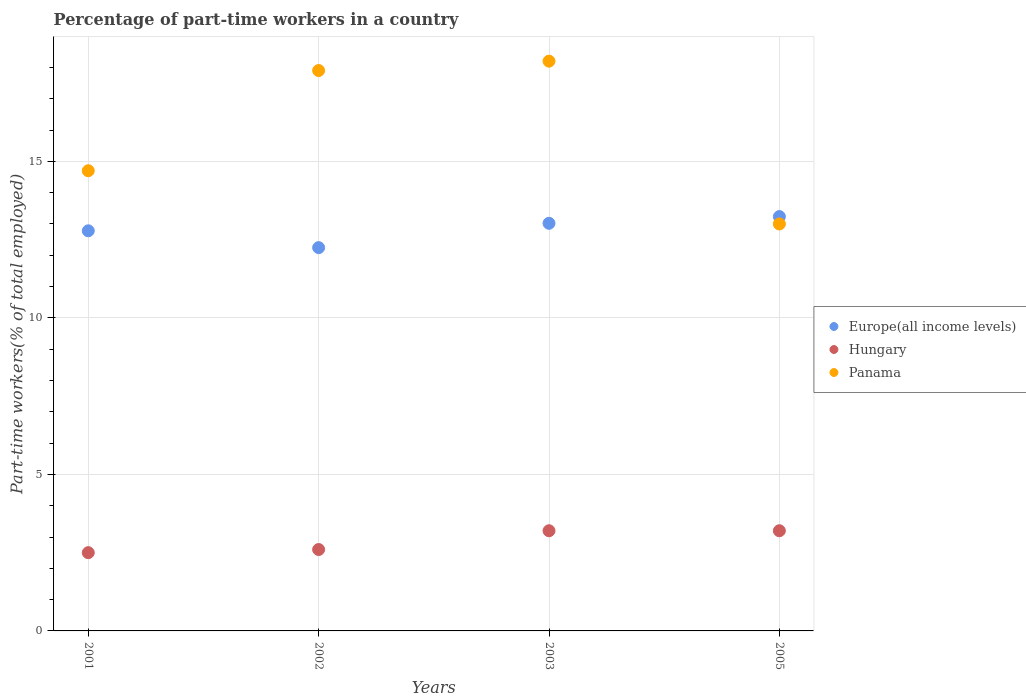How many different coloured dotlines are there?
Offer a very short reply. 3. What is the percentage of part-time workers in Hungary in 2002?
Provide a short and direct response. 2.6. Across all years, what is the maximum percentage of part-time workers in Panama?
Offer a very short reply. 18.2. In which year was the percentage of part-time workers in Hungary maximum?
Provide a succinct answer. 2003. What is the total percentage of part-time workers in Europe(all income levels) in the graph?
Keep it short and to the point. 51.28. What is the difference between the percentage of part-time workers in Europe(all income levels) in 2001 and that in 2005?
Ensure brevity in your answer.  -0.45. What is the difference between the percentage of part-time workers in Panama in 2001 and the percentage of part-time workers in Europe(all income levels) in 2005?
Provide a succinct answer. 1.46. What is the average percentage of part-time workers in Panama per year?
Ensure brevity in your answer.  15.95. In the year 2001, what is the difference between the percentage of part-time workers in Panama and percentage of part-time workers in Europe(all income levels)?
Your response must be concise. 1.92. In how many years, is the percentage of part-time workers in Europe(all income levels) greater than 8 %?
Provide a succinct answer. 4. What is the ratio of the percentage of part-time workers in Panama in 2001 to that in 2005?
Your response must be concise. 1.13. Is the percentage of part-time workers in Hungary in 2001 less than that in 2005?
Ensure brevity in your answer.  Yes. What is the difference between the highest and the second highest percentage of part-time workers in Europe(all income levels)?
Your answer should be compact. 0.21. What is the difference between the highest and the lowest percentage of part-time workers in Europe(all income levels)?
Your response must be concise. 0.99. Is the percentage of part-time workers in Panama strictly greater than the percentage of part-time workers in Hungary over the years?
Your answer should be very brief. Yes. Is the percentage of part-time workers in Panama strictly less than the percentage of part-time workers in Europe(all income levels) over the years?
Your response must be concise. No. How many dotlines are there?
Ensure brevity in your answer.  3. What is the difference between two consecutive major ticks on the Y-axis?
Provide a succinct answer. 5. Does the graph contain any zero values?
Offer a very short reply. No. Where does the legend appear in the graph?
Your response must be concise. Center right. How are the legend labels stacked?
Make the answer very short. Vertical. What is the title of the graph?
Make the answer very short. Percentage of part-time workers in a country. Does "Botswana" appear as one of the legend labels in the graph?
Give a very brief answer. No. What is the label or title of the Y-axis?
Provide a short and direct response. Part-time workers(% of total employed). What is the Part-time workers(% of total employed) in Europe(all income levels) in 2001?
Give a very brief answer. 12.78. What is the Part-time workers(% of total employed) of Panama in 2001?
Provide a short and direct response. 14.7. What is the Part-time workers(% of total employed) in Europe(all income levels) in 2002?
Your answer should be compact. 12.24. What is the Part-time workers(% of total employed) of Hungary in 2002?
Give a very brief answer. 2.6. What is the Part-time workers(% of total employed) in Panama in 2002?
Offer a terse response. 17.9. What is the Part-time workers(% of total employed) in Europe(all income levels) in 2003?
Your answer should be very brief. 13.02. What is the Part-time workers(% of total employed) of Hungary in 2003?
Offer a terse response. 3.2. What is the Part-time workers(% of total employed) in Panama in 2003?
Keep it short and to the point. 18.2. What is the Part-time workers(% of total employed) in Europe(all income levels) in 2005?
Keep it short and to the point. 13.24. What is the Part-time workers(% of total employed) of Hungary in 2005?
Offer a very short reply. 3.2. What is the Part-time workers(% of total employed) of Panama in 2005?
Provide a short and direct response. 13. Across all years, what is the maximum Part-time workers(% of total employed) of Europe(all income levels)?
Make the answer very short. 13.24. Across all years, what is the maximum Part-time workers(% of total employed) of Hungary?
Make the answer very short. 3.2. Across all years, what is the maximum Part-time workers(% of total employed) in Panama?
Provide a succinct answer. 18.2. Across all years, what is the minimum Part-time workers(% of total employed) in Europe(all income levels)?
Keep it short and to the point. 12.24. What is the total Part-time workers(% of total employed) in Europe(all income levels) in the graph?
Your answer should be compact. 51.28. What is the total Part-time workers(% of total employed) in Hungary in the graph?
Ensure brevity in your answer.  11.5. What is the total Part-time workers(% of total employed) in Panama in the graph?
Offer a very short reply. 63.8. What is the difference between the Part-time workers(% of total employed) of Europe(all income levels) in 2001 and that in 2002?
Ensure brevity in your answer.  0.54. What is the difference between the Part-time workers(% of total employed) of Europe(all income levels) in 2001 and that in 2003?
Make the answer very short. -0.24. What is the difference between the Part-time workers(% of total employed) in Europe(all income levels) in 2001 and that in 2005?
Keep it short and to the point. -0.45. What is the difference between the Part-time workers(% of total employed) in Europe(all income levels) in 2002 and that in 2003?
Your answer should be compact. -0.78. What is the difference between the Part-time workers(% of total employed) of Europe(all income levels) in 2002 and that in 2005?
Provide a short and direct response. -0.99. What is the difference between the Part-time workers(% of total employed) in Hungary in 2002 and that in 2005?
Offer a very short reply. -0.6. What is the difference between the Part-time workers(% of total employed) of Europe(all income levels) in 2003 and that in 2005?
Keep it short and to the point. -0.21. What is the difference between the Part-time workers(% of total employed) in Hungary in 2003 and that in 2005?
Offer a very short reply. 0. What is the difference between the Part-time workers(% of total employed) of Europe(all income levels) in 2001 and the Part-time workers(% of total employed) of Hungary in 2002?
Provide a short and direct response. 10.18. What is the difference between the Part-time workers(% of total employed) in Europe(all income levels) in 2001 and the Part-time workers(% of total employed) in Panama in 2002?
Give a very brief answer. -5.12. What is the difference between the Part-time workers(% of total employed) of Hungary in 2001 and the Part-time workers(% of total employed) of Panama in 2002?
Your answer should be compact. -15.4. What is the difference between the Part-time workers(% of total employed) in Europe(all income levels) in 2001 and the Part-time workers(% of total employed) in Hungary in 2003?
Keep it short and to the point. 9.58. What is the difference between the Part-time workers(% of total employed) in Europe(all income levels) in 2001 and the Part-time workers(% of total employed) in Panama in 2003?
Your answer should be compact. -5.42. What is the difference between the Part-time workers(% of total employed) in Hungary in 2001 and the Part-time workers(% of total employed) in Panama in 2003?
Provide a short and direct response. -15.7. What is the difference between the Part-time workers(% of total employed) in Europe(all income levels) in 2001 and the Part-time workers(% of total employed) in Hungary in 2005?
Provide a short and direct response. 9.58. What is the difference between the Part-time workers(% of total employed) in Europe(all income levels) in 2001 and the Part-time workers(% of total employed) in Panama in 2005?
Keep it short and to the point. -0.22. What is the difference between the Part-time workers(% of total employed) of Hungary in 2001 and the Part-time workers(% of total employed) of Panama in 2005?
Give a very brief answer. -10.5. What is the difference between the Part-time workers(% of total employed) of Europe(all income levels) in 2002 and the Part-time workers(% of total employed) of Hungary in 2003?
Provide a short and direct response. 9.04. What is the difference between the Part-time workers(% of total employed) in Europe(all income levels) in 2002 and the Part-time workers(% of total employed) in Panama in 2003?
Your answer should be very brief. -5.96. What is the difference between the Part-time workers(% of total employed) in Hungary in 2002 and the Part-time workers(% of total employed) in Panama in 2003?
Provide a succinct answer. -15.6. What is the difference between the Part-time workers(% of total employed) in Europe(all income levels) in 2002 and the Part-time workers(% of total employed) in Hungary in 2005?
Make the answer very short. 9.04. What is the difference between the Part-time workers(% of total employed) of Europe(all income levels) in 2002 and the Part-time workers(% of total employed) of Panama in 2005?
Make the answer very short. -0.76. What is the difference between the Part-time workers(% of total employed) of Europe(all income levels) in 2003 and the Part-time workers(% of total employed) of Hungary in 2005?
Your answer should be compact. 9.82. What is the difference between the Part-time workers(% of total employed) of Europe(all income levels) in 2003 and the Part-time workers(% of total employed) of Panama in 2005?
Make the answer very short. 0.02. What is the difference between the Part-time workers(% of total employed) in Hungary in 2003 and the Part-time workers(% of total employed) in Panama in 2005?
Your answer should be very brief. -9.8. What is the average Part-time workers(% of total employed) in Europe(all income levels) per year?
Provide a short and direct response. 12.82. What is the average Part-time workers(% of total employed) of Hungary per year?
Your answer should be very brief. 2.88. What is the average Part-time workers(% of total employed) of Panama per year?
Your response must be concise. 15.95. In the year 2001, what is the difference between the Part-time workers(% of total employed) in Europe(all income levels) and Part-time workers(% of total employed) in Hungary?
Your answer should be compact. 10.28. In the year 2001, what is the difference between the Part-time workers(% of total employed) of Europe(all income levels) and Part-time workers(% of total employed) of Panama?
Provide a succinct answer. -1.92. In the year 2002, what is the difference between the Part-time workers(% of total employed) of Europe(all income levels) and Part-time workers(% of total employed) of Hungary?
Offer a very short reply. 9.64. In the year 2002, what is the difference between the Part-time workers(% of total employed) of Europe(all income levels) and Part-time workers(% of total employed) of Panama?
Your response must be concise. -5.66. In the year 2002, what is the difference between the Part-time workers(% of total employed) in Hungary and Part-time workers(% of total employed) in Panama?
Offer a very short reply. -15.3. In the year 2003, what is the difference between the Part-time workers(% of total employed) in Europe(all income levels) and Part-time workers(% of total employed) in Hungary?
Keep it short and to the point. 9.82. In the year 2003, what is the difference between the Part-time workers(% of total employed) in Europe(all income levels) and Part-time workers(% of total employed) in Panama?
Make the answer very short. -5.18. In the year 2003, what is the difference between the Part-time workers(% of total employed) in Hungary and Part-time workers(% of total employed) in Panama?
Your answer should be compact. -15. In the year 2005, what is the difference between the Part-time workers(% of total employed) of Europe(all income levels) and Part-time workers(% of total employed) of Hungary?
Your response must be concise. 10.04. In the year 2005, what is the difference between the Part-time workers(% of total employed) of Europe(all income levels) and Part-time workers(% of total employed) of Panama?
Ensure brevity in your answer.  0.24. What is the ratio of the Part-time workers(% of total employed) in Europe(all income levels) in 2001 to that in 2002?
Ensure brevity in your answer.  1.04. What is the ratio of the Part-time workers(% of total employed) in Hungary in 2001 to that in 2002?
Provide a succinct answer. 0.96. What is the ratio of the Part-time workers(% of total employed) of Panama in 2001 to that in 2002?
Offer a terse response. 0.82. What is the ratio of the Part-time workers(% of total employed) of Europe(all income levels) in 2001 to that in 2003?
Keep it short and to the point. 0.98. What is the ratio of the Part-time workers(% of total employed) in Hungary in 2001 to that in 2003?
Offer a terse response. 0.78. What is the ratio of the Part-time workers(% of total employed) in Panama in 2001 to that in 2003?
Give a very brief answer. 0.81. What is the ratio of the Part-time workers(% of total employed) in Europe(all income levels) in 2001 to that in 2005?
Provide a short and direct response. 0.97. What is the ratio of the Part-time workers(% of total employed) of Hungary in 2001 to that in 2005?
Keep it short and to the point. 0.78. What is the ratio of the Part-time workers(% of total employed) in Panama in 2001 to that in 2005?
Keep it short and to the point. 1.13. What is the ratio of the Part-time workers(% of total employed) in Europe(all income levels) in 2002 to that in 2003?
Give a very brief answer. 0.94. What is the ratio of the Part-time workers(% of total employed) of Hungary in 2002 to that in 2003?
Your answer should be compact. 0.81. What is the ratio of the Part-time workers(% of total employed) in Panama in 2002 to that in 2003?
Offer a very short reply. 0.98. What is the ratio of the Part-time workers(% of total employed) of Europe(all income levels) in 2002 to that in 2005?
Keep it short and to the point. 0.93. What is the ratio of the Part-time workers(% of total employed) of Hungary in 2002 to that in 2005?
Offer a very short reply. 0.81. What is the ratio of the Part-time workers(% of total employed) in Panama in 2002 to that in 2005?
Your answer should be compact. 1.38. What is the ratio of the Part-time workers(% of total employed) in Europe(all income levels) in 2003 to that in 2005?
Ensure brevity in your answer.  0.98. What is the ratio of the Part-time workers(% of total employed) of Hungary in 2003 to that in 2005?
Your answer should be very brief. 1. What is the difference between the highest and the second highest Part-time workers(% of total employed) of Europe(all income levels)?
Ensure brevity in your answer.  0.21. What is the difference between the highest and the second highest Part-time workers(% of total employed) of Hungary?
Make the answer very short. 0. What is the difference between the highest and the second highest Part-time workers(% of total employed) in Panama?
Keep it short and to the point. 0.3. What is the difference between the highest and the lowest Part-time workers(% of total employed) in Hungary?
Your response must be concise. 0.7. What is the difference between the highest and the lowest Part-time workers(% of total employed) in Panama?
Offer a terse response. 5.2. 